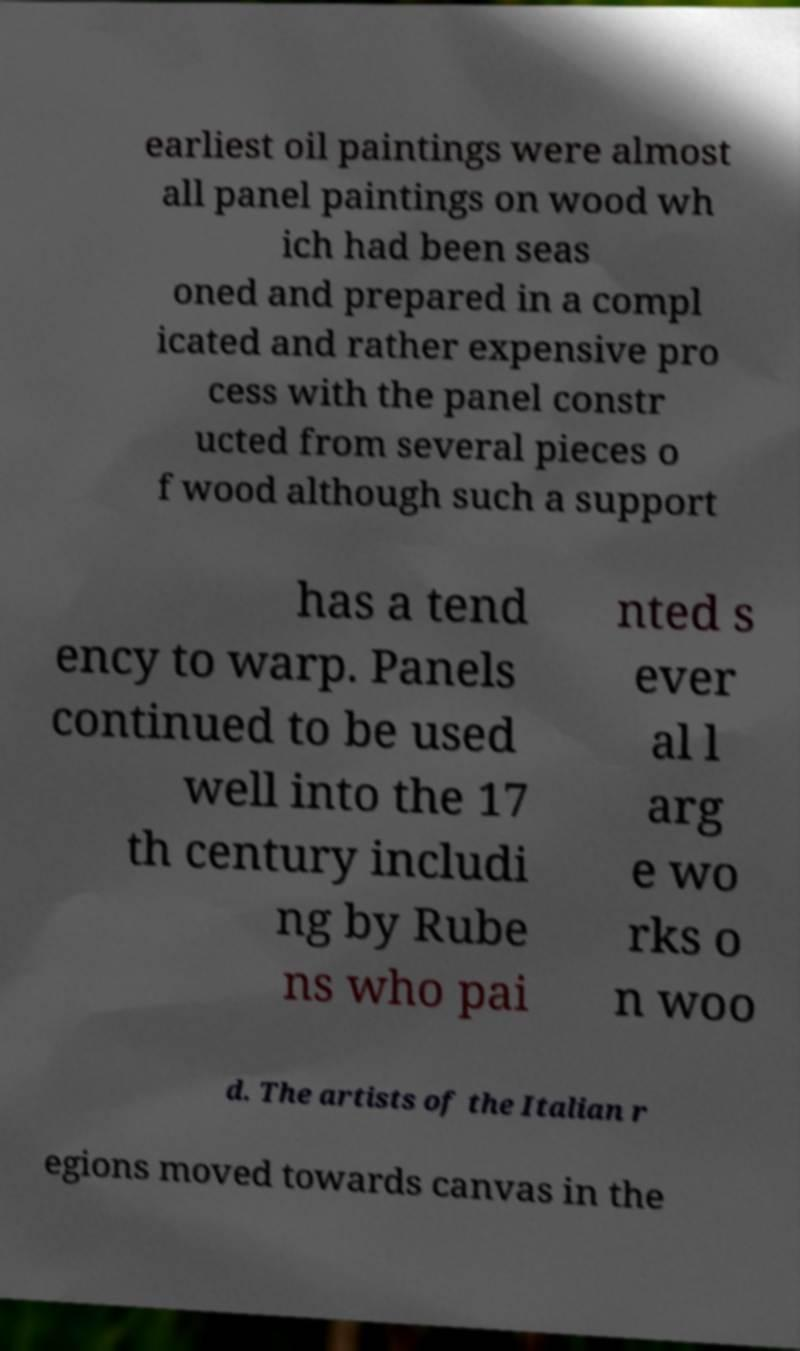There's text embedded in this image that I need extracted. Can you transcribe it verbatim? earliest oil paintings were almost all panel paintings on wood wh ich had been seas oned and prepared in a compl icated and rather expensive pro cess with the panel constr ucted from several pieces o f wood although such a support has a tend ency to warp. Panels continued to be used well into the 17 th century includi ng by Rube ns who pai nted s ever al l arg e wo rks o n woo d. The artists of the Italian r egions moved towards canvas in the 